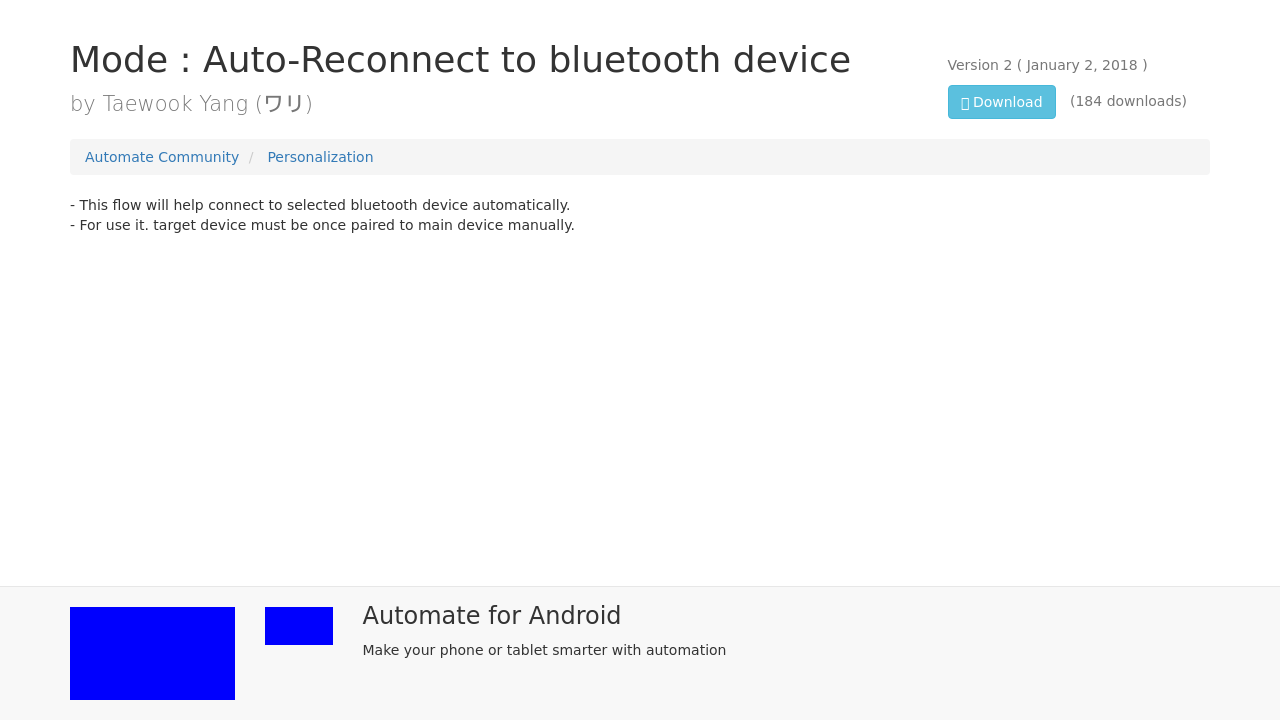What can you tell me about the 'Automate for Android' app promoted in the image? The 'Automate for Android' app seems to be an application that allows users to create automated tasks on their Android devices. The image suggests that the app encourages making your phone or tablet smarter through automation, implying features that streamline or handle tasks based on triggers or conditions set by the user. 